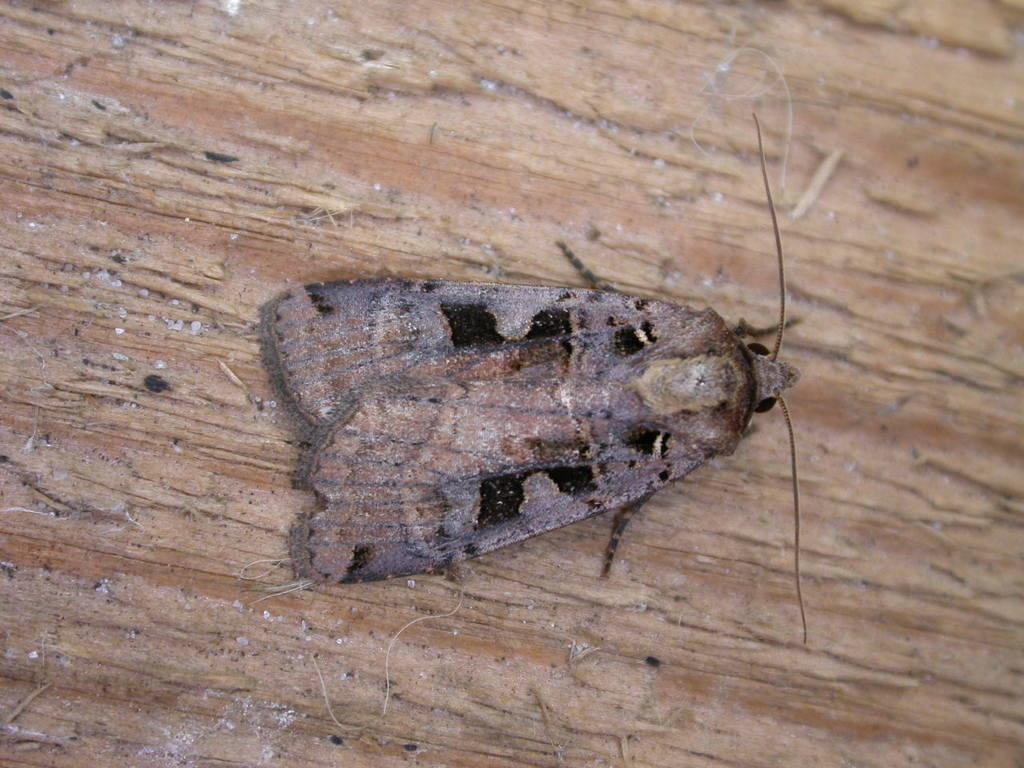Could you give a brief overview of what you see in this image? In this picture there is a wood table, on that wood table, we can see a insect which is in brown color. 